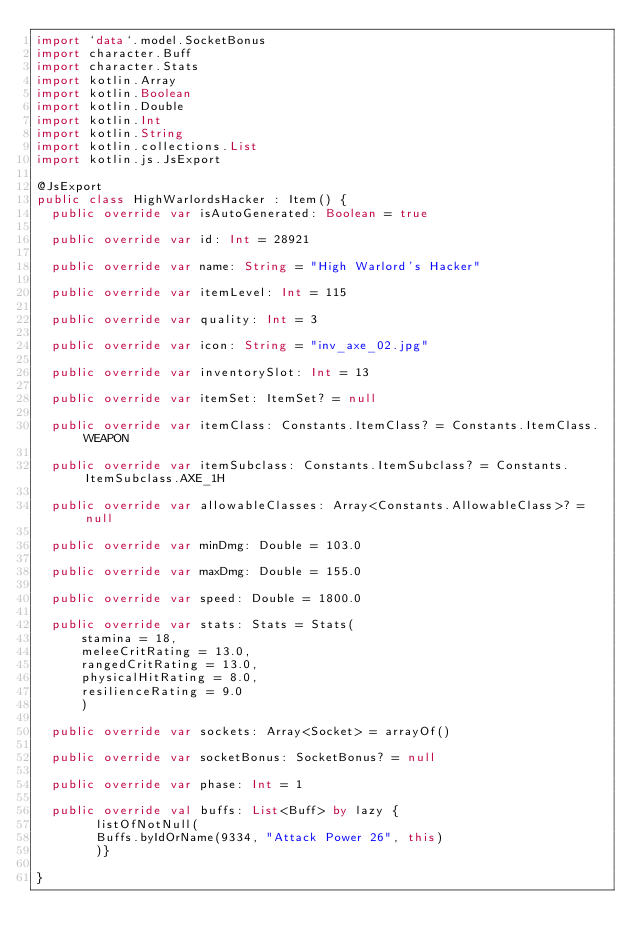Convert code to text. <code><loc_0><loc_0><loc_500><loc_500><_Kotlin_>import `data`.model.SocketBonus
import character.Buff
import character.Stats
import kotlin.Array
import kotlin.Boolean
import kotlin.Double
import kotlin.Int
import kotlin.String
import kotlin.collections.List
import kotlin.js.JsExport

@JsExport
public class HighWarlordsHacker : Item() {
  public override var isAutoGenerated: Boolean = true

  public override var id: Int = 28921

  public override var name: String = "High Warlord's Hacker"

  public override var itemLevel: Int = 115

  public override var quality: Int = 3

  public override var icon: String = "inv_axe_02.jpg"

  public override var inventorySlot: Int = 13

  public override var itemSet: ItemSet? = null

  public override var itemClass: Constants.ItemClass? = Constants.ItemClass.WEAPON

  public override var itemSubclass: Constants.ItemSubclass? = Constants.ItemSubclass.AXE_1H

  public override var allowableClasses: Array<Constants.AllowableClass>? = null

  public override var minDmg: Double = 103.0

  public override var maxDmg: Double = 155.0

  public override var speed: Double = 1800.0

  public override var stats: Stats = Stats(
      stamina = 18,
      meleeCritRating = 13.0,
      rangedCritRating = 13.0,
      physicalHitRating = 8.0,
      resilienceRating = 9.0
      )

  public override var sockets: Array<Socket> = arrayOf()

  public override var socketBonus: SocketBonus? = null

  public override var phase: Int = 1

  public override val buffs: List<Buff> by lazy {
        listOfNotNull(
        Buffs.byIdOrName(9334, "Attack Power 26", this)
        )}

}
</code> 